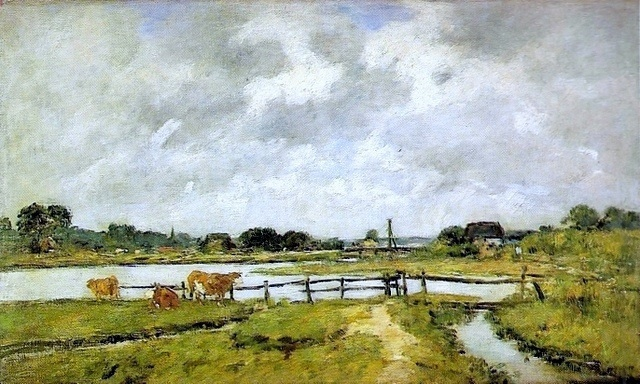Describe the objects in this image and their specific colors. I can see cow in gray, olive, tan, and maroon tones, cow in gray, olive, and tan tones, and cow in gray, brown, and maroon tones in this image. 